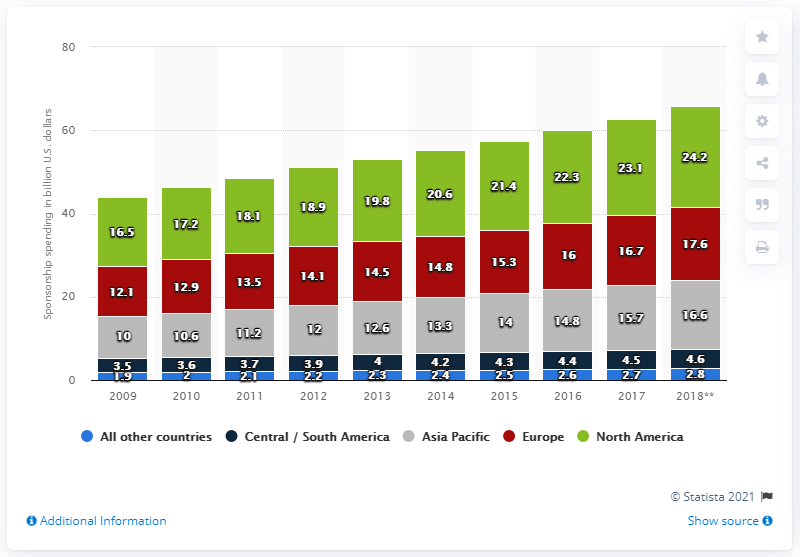List a handful of essential elements in this visual. In 2014, the value of the green bar was 20.6. In 2017, the amount of money spent on sponsorship in Europe was 16.6 billion U.S. dollars. In 2017, the value of the red bar is 16.7. 